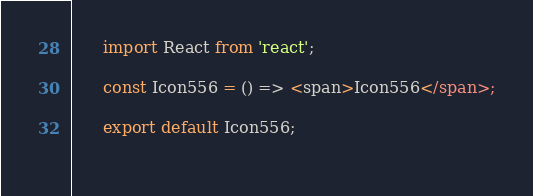<code> <loc_0><loc_0><loc_500><loc_500><_JavaScript_>
      import React from 'react';

      const Icon556 = () => <span>Icon556</span>;
      
      export default Icon556;
    </code> 